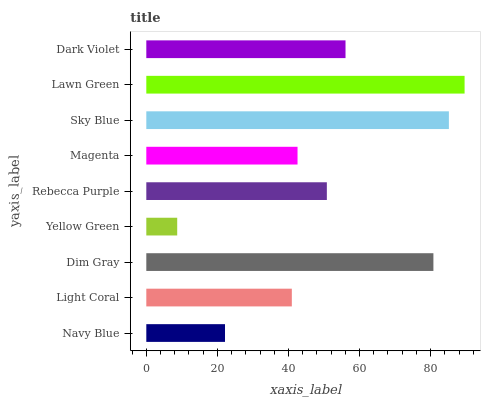Is Yellow Green the minimum?
Answer yes or no. Yes. Is Lawn Green the maximum?
Answer yes or no. Yes. Is Light Coral the minimum?
Answer yes or no. No. Is Light Coral the maximum?
Answer yes or no. No. Is Light Coral greater than Navy Blue?
Answer yes or no. Yes. Is Navy Blue less than Light Coral?
Answer yes or no. Yes. Is Navy Blue greater than Light Coral?
Answer yes or no. No. Is Light Coral less than Navy Blue?
Answer yes or no. No. Is Rebecca Purple the high median?
Answer yes or no. Yes. Is Rebecca Purple the low median?
Answer yes or no. Yes. Is Yellow Green the high median?
Answer yes or no. No. Is Dim Gray the low median?
Answer yes or no. No. 